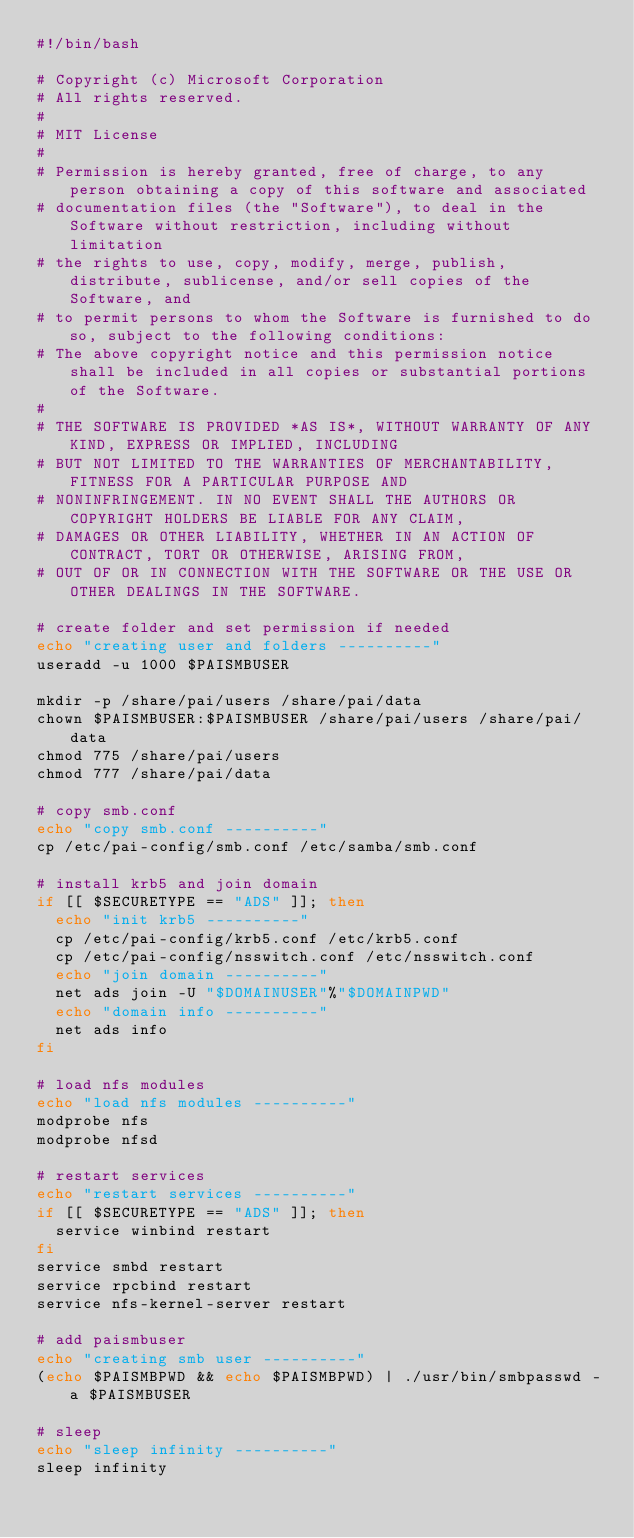Convert code to text. <code><loc_0><loc_0><loc_500><loc_500><_Bash_>#!/bin/bash

# Copyright (c) Microsoft Corporation
# All rights reserved.
#
# MIT License
#
# Permission is hereby granted, free of charge, to any person obtaining a copy of this software and associated
# documentation files (the "Software"), to deal in the Software without restriction, including without limitation
# the rights to use, copy, modify, merge, publish, distribute, sublicense, and/or sell copies of the Software, and
# to permit persons to whom the Software is furnished to do so, subject to the following conditions:
# The above copyright notice and this permission notice shall be included in all copies or substantial portions of the Software.
#
# THE SOFTWARE IS PROVIDED *AS IS*, WITHOUT WARRANTY OF ANY KIND, EXPRESS OR IMPLIED, INCLUDING
# BUT NOT LIMITED TO THE WARRANTIES OF MERCHANTABILITY, FITNESS FOR A PARTICULAR PURPOSE AND
# NONINFRINGEMENT. IN NO EVENT SHALL THE AUTHORS OR COPYRIGHT HOLDERS BE LIABLE FOR ANY CLAIM,
# DAMAGES OR OTHER LIABILITY, WHETHER IN AN ACTION OF CONTRACT, TORT OR OTHERWISE, ARISING FROM,
# OUT OF OR IN CONNECTION WITH THE SOFTWARE OR THE USE OR OTHER DEALINGS IN THE SOFTWARE.

# create folder and set permission if needed
echo "creating user and folders ----------"
useradd -u 1000 $PAISMBUSER

mkdir -p /share/pai/users /share/pai/data
chown $PAISMBUSER:$PAISMBUSER /share/pai/users /share/pai/data
chmod 775 /share/pai/users
chmod 777 /share/pai/data

# copy smb.conf
echo "copy smb.conf ----------"
cp /etc/pai-config/smb.conf /etc/samba/smb.conf

# install krb5 and join domain
if [[ $SECURETYPE == "ADS" ]]; then
  echo "init krb5 ----------"
  cp /etc/pai-config/krb5.conf /etc/krb5.conf
  cp /etc/pai-config/nsswitch.conf /etc/nsswitch.conf
  echo "join domain ----------"
  net ads join -U "$DOMAINUSER"%"$DOMAINPWD"
  echo "domain info ----------"
  net ads info
fi

# load nfs modules
echo "load nfs modules ----------"
modprobe nfs
modprobe nfsd

# restart services
echo "restart services ----------"
if [[ $SECURETYPE == "ADS" ]]; then
  service winbind restart
fi
service smbd restart
service rpcbind restart
service nfs-kernel-server restart

# add paismbuser
echo "creating smb user ----------"
(echo $PAISMBPWD && echo $PAISMBPWD) | ./usr/bin/smbpasswd -a $PAISMBUSER

# sleep
echo "sleep infinity ----------"
sleep infinity
</code> 